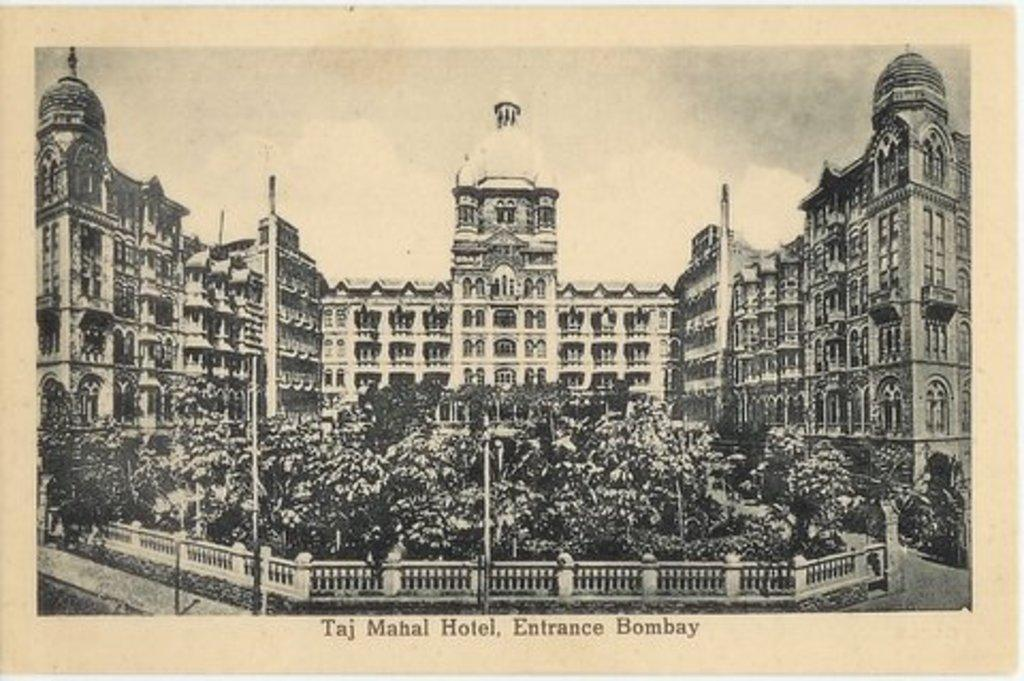<image>
Describe the image concisely. An old postcard from the Taj Mahal Hotel shows the building and the grounds in front of it. 